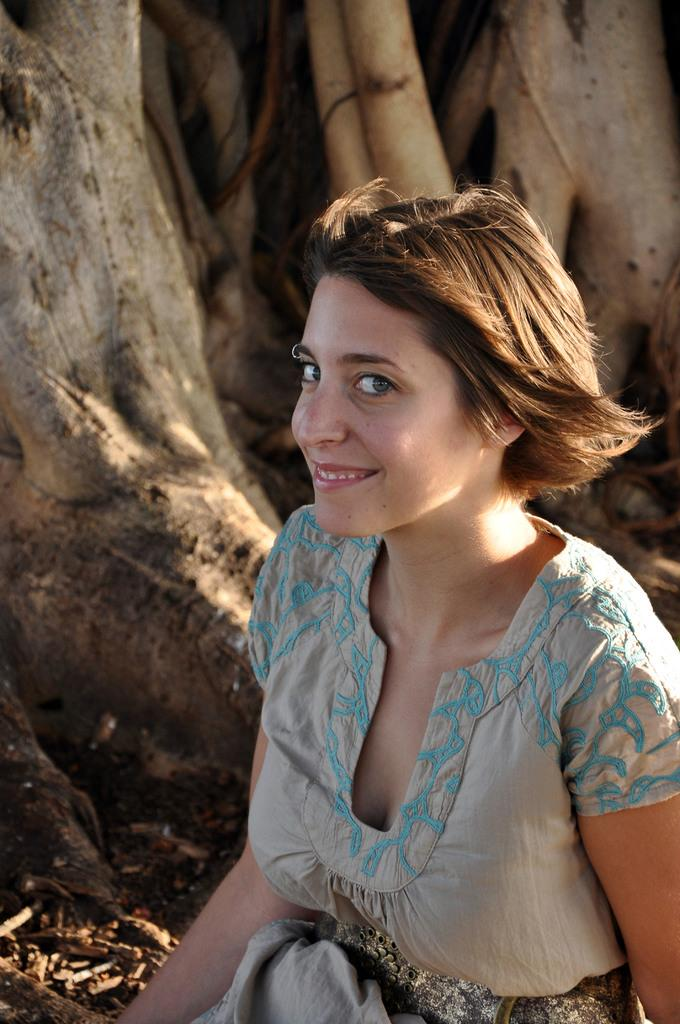Who is the main subject in the image? There is a woman in the image. Where is the woman located in the image? The woman is in the front of the image. What is the woman's facial expression? The woman is smiling. What can be seen in the background of the image? There are objects in the background of the image. Are there any cobwebs visible in the image? There is no mention of cobwebs in the provided facts, so we cannot determine if they are present in the image. 